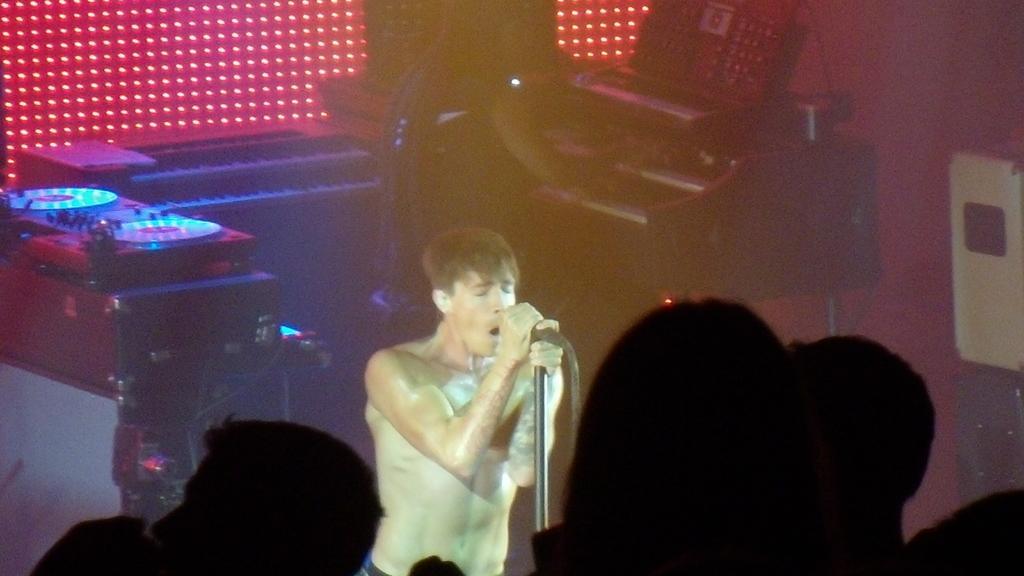Describe this image in one or two sentences. On the right side if the image we can see some musical instruments and a piano. In the middle of the image we can see a person holding a mike and singing a song because his mouth is open and back of him another person is playing an instrument. On the left side of the image we can box and some persons. 